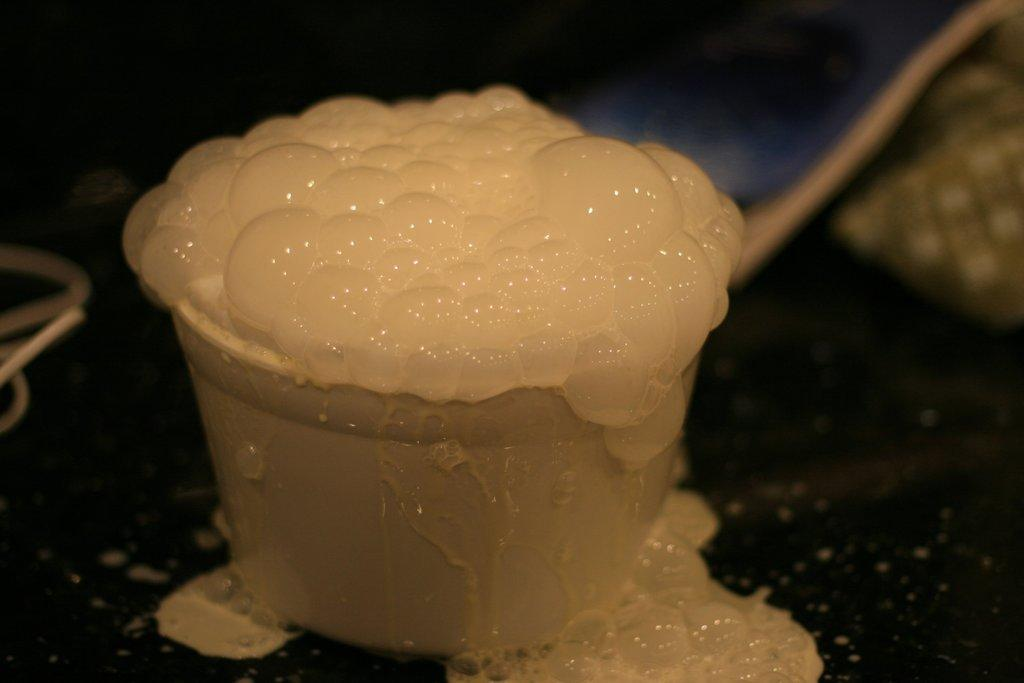What is present on the paper in the image? The facts provided do not specify any details about the paper in the image. What is the glass in the image used for? The glass in the image is used to hold a soft drink. On what surface is the glass placed? The glass is on a surface in the image. What type of beverage is in the glass? There is a soft drink in the glass. How many times has the paper been bitten by the dog in the image? There is no dog present in the image, and therefore no biting has occurred. What unit of measurement is used to determine the size of the soft drink in the glass? The facts provided do not specify any details about the measurement of the soft drink in the glass. 